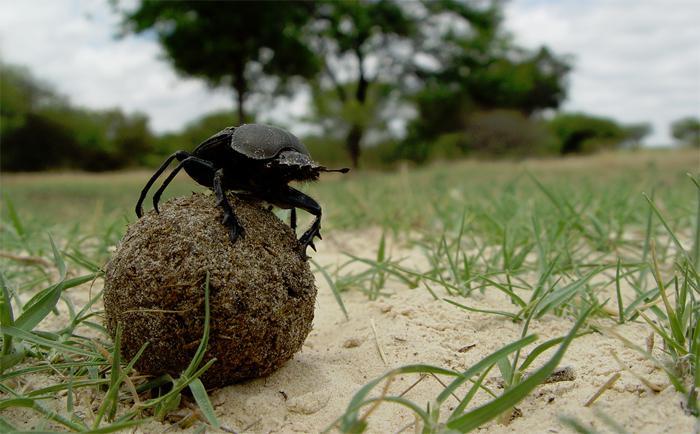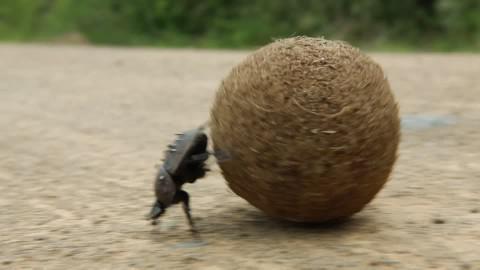The first image is the image on the left, the second image is the image on the right. Assess this claim about the two images: "There is exactly one insect standing on top of the ball in one of the images.". Correct or not? Answer yes or no. Yes. 